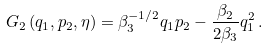<formula> <loc_0><loc_0><loc_500><loc_500>G _ { 2 } \left ( q _ { 1 } , p _ { 2 } , \eta \right ) = \beta _ { 3 } ^ { - 1 / 2 } q _ { 1 } p _ { 2 } - \frac { \beta _ { 2 } } { 2 \beta _ { 3 } } q _ { 1 } ^ { 2 } \, .</formula> 